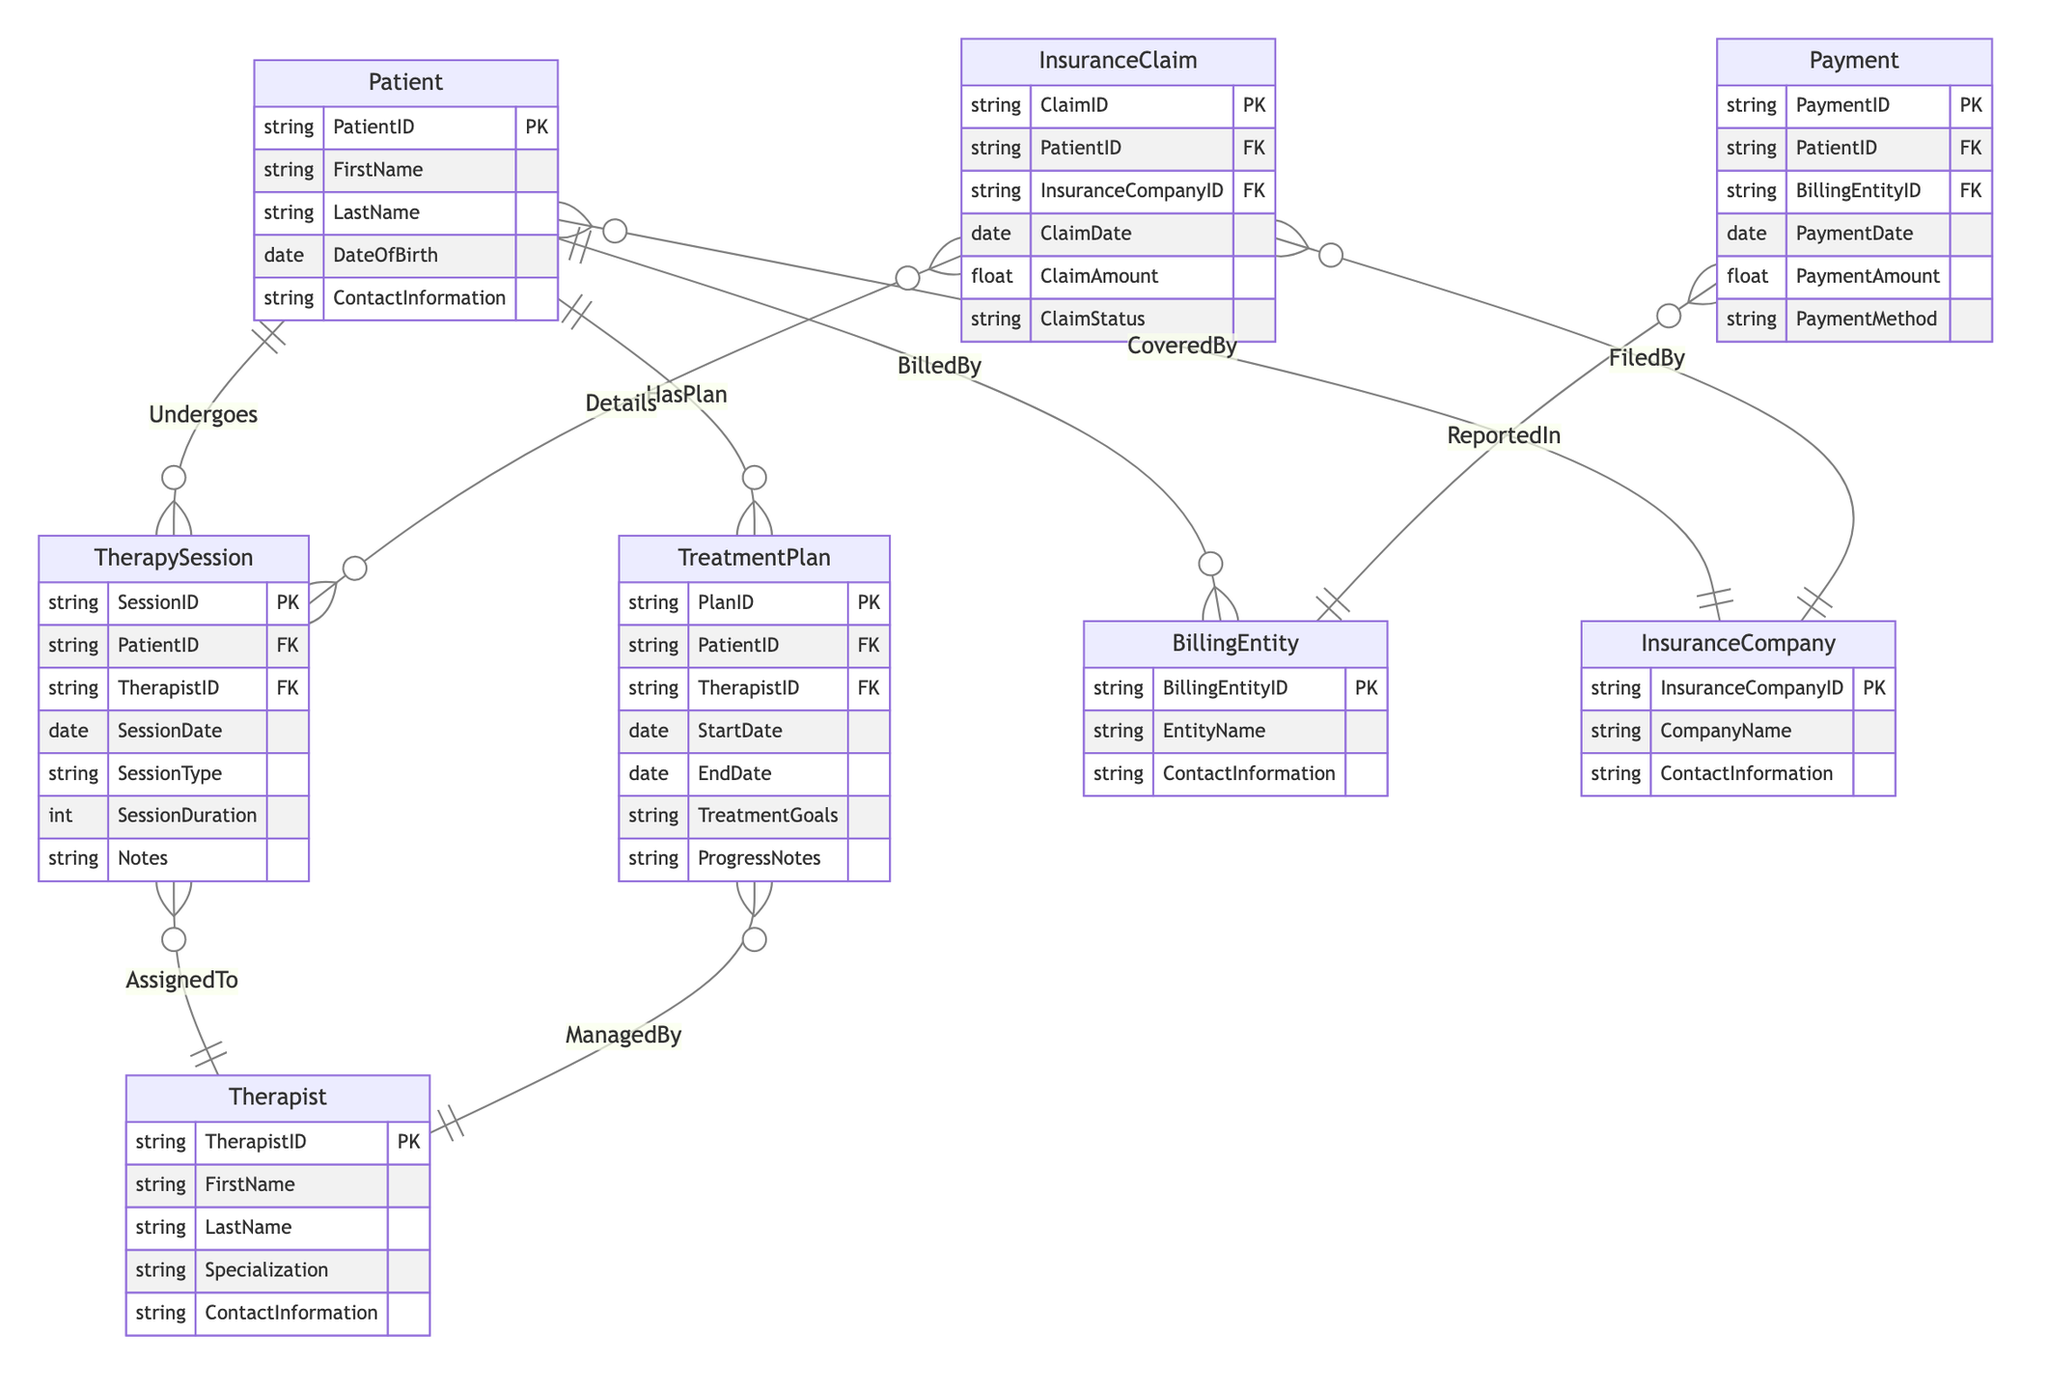What is the primary key of the Patient entity? The diagram indicates that the Patient entity has a primary key attribute labeled 'PatientID', which uniquely identifies each patient in the system.
Answer: PatientID How many therapy sessions can a patient undergo? According to the relationship represented in the diagram, the "Undergoes" relationship between Patient and TherapySession has a cardinality of 1:M, indicating that one patient can have multiple therapy sessions.
Answer: Multiple What relationship exists between TherapySession and Therapist? The diagram shows a relationship named "AssignedTo" between the TherapySession and Therapist entities, indicating that each therapy session is assigned to one therapist.
Answer: AssignedTo Which entity manages the treatment plans? The diagram reveals a relationship called "ManagedBy", indicating that Therapist entities manage TreatmentPlans. This relationship denotes the oversight of treatment plans by therapists.
Answer: Therapist How many payments can be associated with a single billing entity? The diagram specifies a "ReportedIn" relationship between Payment and BillingEntity entities with cardinality M:1, meaning that multiple payments can be reported in one billing entity.
Answer: Multiple What entity is associated with filing insurance claims? The diagram contains a relationship called "FiledBy" that connects InsuranceClaim entities with InsuranceCompany entities, denoting that insurance claims are filed by insurance companies.
Answer: InsuranceCompany What is the cardinality of the relationship between a patient and their treatment plans? The relationship called "HasPlan" is shown between Patient and TreatmentPlan with cardinality 1:M, indicating that a patient can have multiple treatment plans.
Answer: 1:M Which entity is directly linked to making payments? The diagram specifies the Payment entity, which is tied to the Patient and BillingEntity. This indicates that payments are made by patients to billing entities.
Answer: Payment What is represented by the relationship named "Details"? The "Details" relationship in the diagram illustrates a many-to-many connection between InsuranceClaim and TherapySession entities, indicating that multiple therapy sessions can be associated with multiple insurance claims.
Answer: Many-to-many 